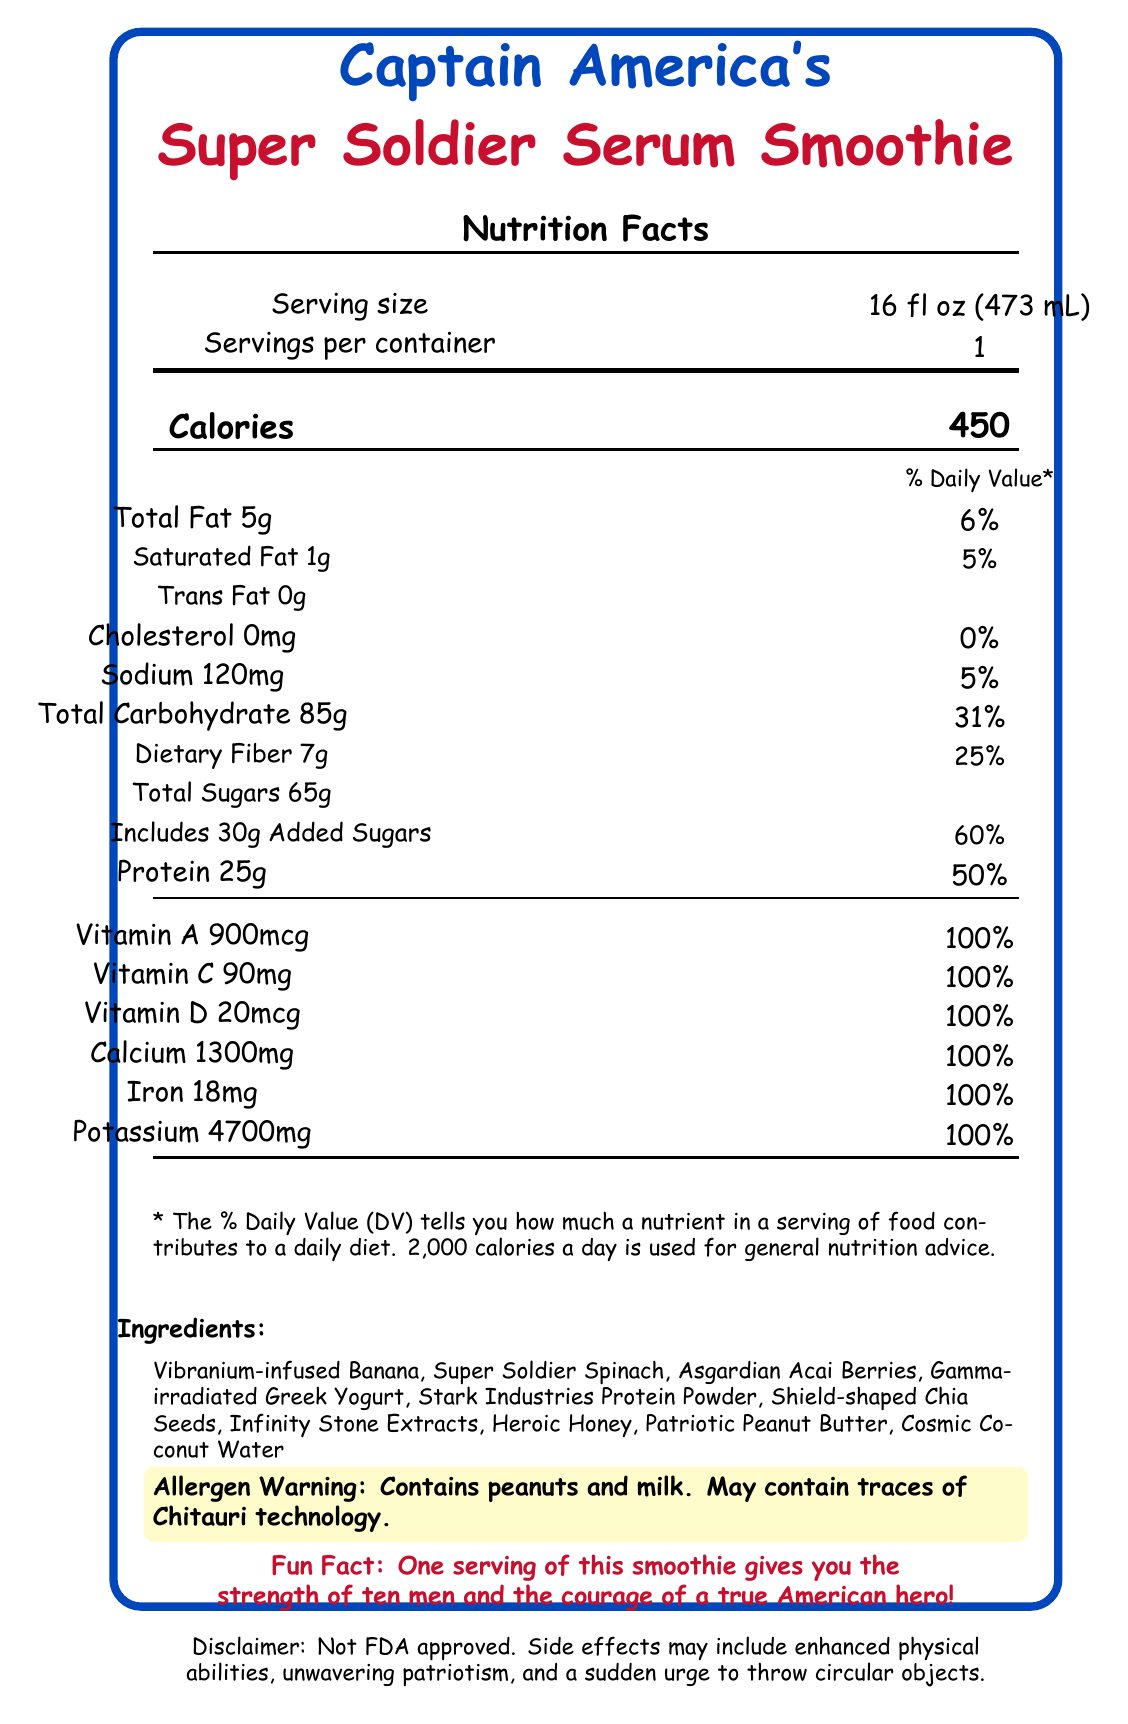how many calories are in one serving of the smoothie? The "Calories" section in the nutrition facts box lists 450 calories per serving.
Answer: 450 what is the serving size of Captain America's Super Soldier Serum Smoothie? The "Serving size" section of the nutrition facts box states that it is 16 fl oz (473 mL).
Answer: 16 fl oz (473 mL) how much protein is in one serving? The "Protein" section of the nutrition facts box lists 25g per serving.
Answer: 25g how much sugar does the smoothie contain? The "Total Sugars" section in the nutrition facts box lists 65g sugars per serving.
Answer: 65g what percentage of Daily Value does calcium contribute? The "Calcium" section in the nutrition facts box indicates it contributes 100% of the daily value.
Answer: 100% what ingredients are included in the smoothie? The "Ingredients" section lists all the components: Vibranium-infused Banana, Super Soldier Spinach, Asgardian Acai Berries, Gamma-irradiated Greek Yogurt, Stark Industries Protein Powder, Shield-shaped Chia Seeds, Infinity Stone Extracts, Heroic Honey, Patriotic Peanut Butter, and Cosmic Coconut Water.
Answer: Vibranium-infused Banana, Super Soldier Spinach, Asgardian Acai Berries, Gamma-irradiated Greek Yogurt, Stark Industries Protein Powder, Shield-shaped Chia Seeds, Infinity Stone Extracts, Heroic Honey, Patriotic Peanut Butter, Cosmic Coconut Water how much added sugar is in the smoothie? The "Includes Added Sugars" section in the nutrition facts box lists 30g of added sugars.
Answer: 30g which vitamin is NOT listed as 100% of daily value: A, B, C, D, or E? The document lists Vitamin A, C, and D as 100%. Vitamin B and E are not listed.
Answer: B or E is there any cholesterol in the smoothie? The "Cholesterol" section in the nutrition facts box lists 0mg which is 0% of the daily value.
Answer: No which ingredient might cause an allergic reaction? A. Cosmic Coconut Water, B. Patriotic Peanut Butter, C. Infinity Stone Extracts The allergen warning mentions the presence of peanuts and milk, and Patriotic Peanut Butter would contain peanuts.
Answer: B how many servings are there per container? The "Servings per container" section in the nutrition facts box indicates there is 1 serving per container.
Answer: 1 is this smoothie approved by the FDA? The disclaimer clearly states that it's "Not FDA approved."
Answer: No what side effects might you experience from drinking this smoothie? The disclaimer lists these as potential side effects.
Answer: Enhanced physical abilities, unwavering patriotism, and a sudden urge to throw circular objects what percentage of Daily Value for dietary fiber does the smoothie provide? The "Dietary Fiber" section in the nutrition facts box lists it as 25% of the daily value.
Answer: 25% summarize the main idea of the document The document outlines the nutrition facts of the product, including serving size, calorie content, fat, carbohydrates, proteins, vitamins, ingredients, and potential risks, presented in a thematic and heroic style related to Captain America.
Answer: The document provides detailed nutrition information about Captain America's Super Soldier Serum Smoothie, listing its serving size, calories, macronutrients, vitamins, ingredients, allergen warnings, and potential side effects, with an emphasis on its heroic and thematic elements. what is the main effect of consuming one serving according to the fun fact? The "Fun Fact" section states that one serving provides the strength of ten men and the courage of a true American hero.
Answer: Strength of ten men and the courage of a true American hero how is the Vitamin A content of this smoothie presented? The "Vitamin A" section of the nutrition facts box lists it as 900mcg.
Answer: 900mcg what is the sodium content of the smoothie in milligrams? A. 120mg B. 150mg C. 200mg D. 250mg The "Sodium" section in the nutrition facts box lists 120mg.
Answer: A what's the total fat percentage of Daily Value contained in one serving? The "Total Fat" section in the nutrition facts box mentions that it is 6% of the daily value.
Answer: 6% why does the smoothie contain Gamma-irradiated Greek Yogurt? The document mentions the ingredient, but no further explanation is provided as to why it contains Gamma-irradiated Greek Yogurt.
Answer: Cannot be determined 